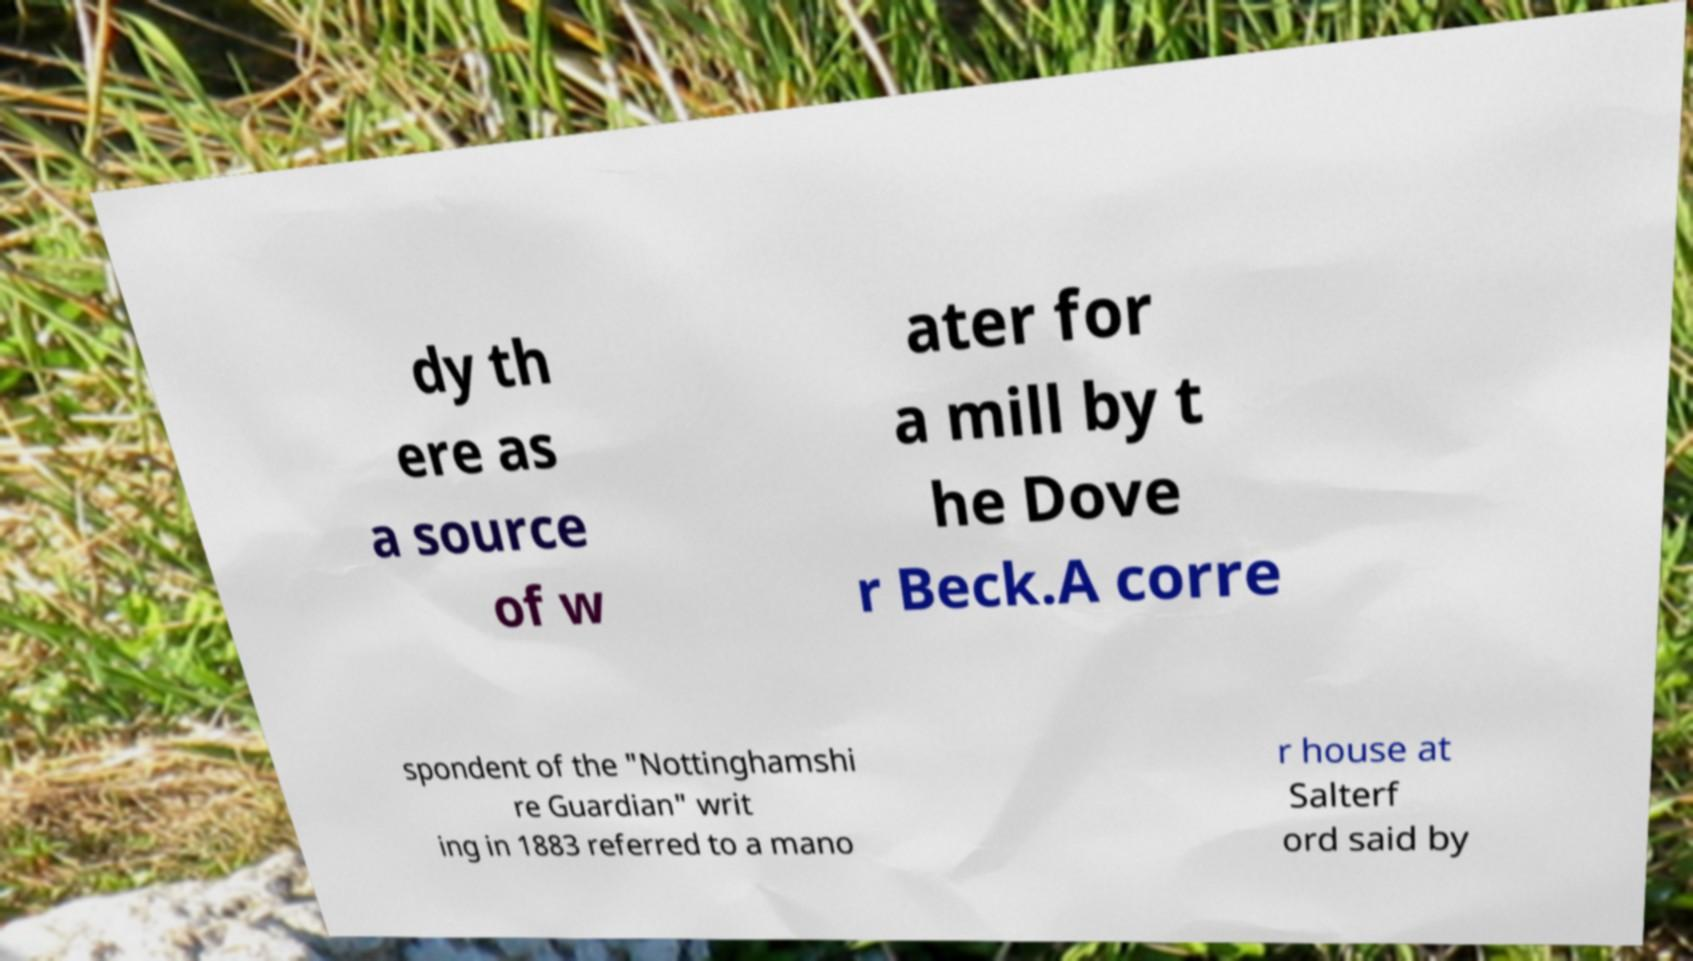Could you extract and type out the text from this image? dy th ere as a source of w ater for a mill by t he Dove r Beck.A corre spondent of the "Nottinghamshi re Guardian" writ ing in 1883 referred to a mano r house at Salterf ord said by 